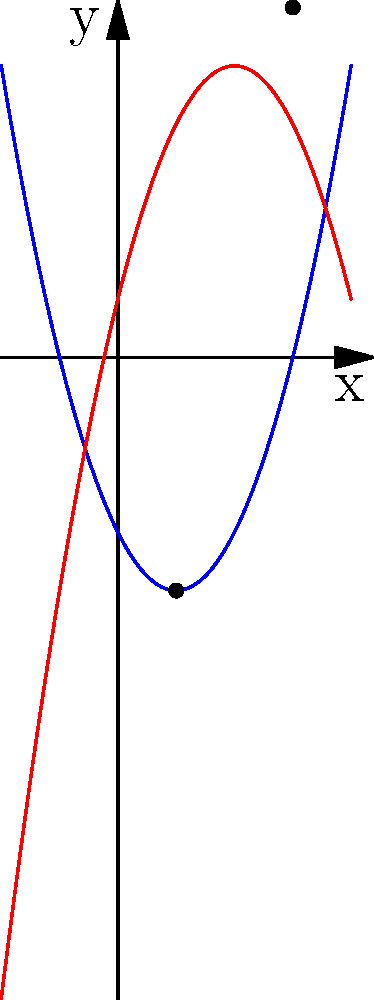Given the polynomial functions $f(x) = x^2 - 2x - 3$ and $g(x) = -x^2 + 4x + 1$, determine the x-coordinates of their intersection points as shown in the graph above. To find the intersection points, we need to solve the equation $f(x) = g(x)$:

1) Set up the equation:
   $x^2 - 2x - 3 = -x^2 + 4x + 1$

2) Rearrange terms:
   $x^2 - 2x - 3 + x^2 - 4x - 1 = 0$
   $2x^2 - 6x - 4 = 0$

3) Simplify:
   $x^2 - 3x - 2 = 0$

4) Use the quadratic formula: $x = \frac{-b \pm \sqrt{b^2 - 4ac}}{2a}$
   Where $a = 1$, $b = -3$, and $c = -2$

5) Substitute into the formula:
   $x = \frac{3 \pm \sqrt{(-3)^2 - 4(1)(-2)}}{2(1)}$
   $x = \frac{3 \pm \sqrt{9 + 8}}{2}$
   $x = \frac{3 \pm \sqrt{17}}{2}$

6) Simplify:
   $x = \frac{3 + \sqrt{17}}{2}$ or $x = \frac{3 - \sqrt{17}}{2}$

7) Calculate approximate values:
   $x \approx 3$ or $x \approx 1$

These x-coordinates correspond to the intersection points visible in the graph.
Answer: $x = 1$ and $x = 3$ 